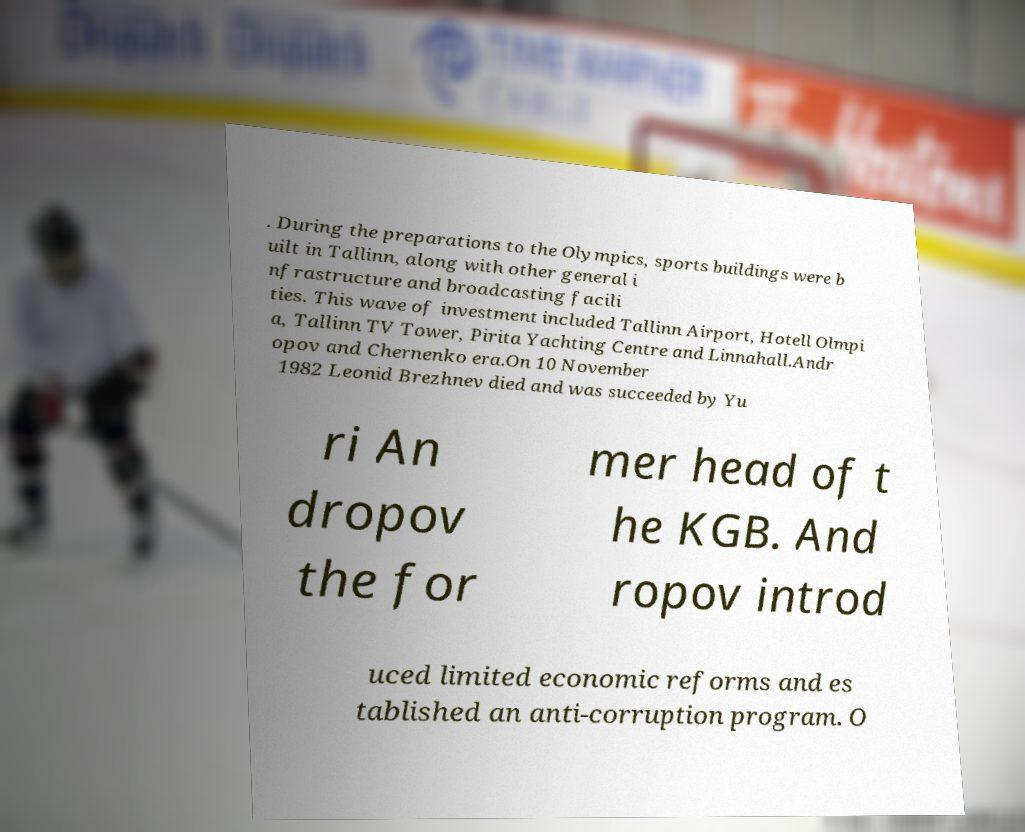Please identify and transcribe the text found in this image. . During the preparations to the Olympics, sports buildings were b uilt in Tallinn, along with other general i nfrastructure and broadcasting facili ties. This wave of investment included Tallinn Airport, Hotell Olmpi a, Tallinn TV Tower, Pirita Yachting Centre and Linnahall.Andr opov and Chernenko era.On 10 November 1982 Leonid Brezhnev died and was succeeded by Yu ri An dropov the for mer head of t he KGB. And ropov introd uced limited economic reforms and es tablished an anti-corruption program. O 